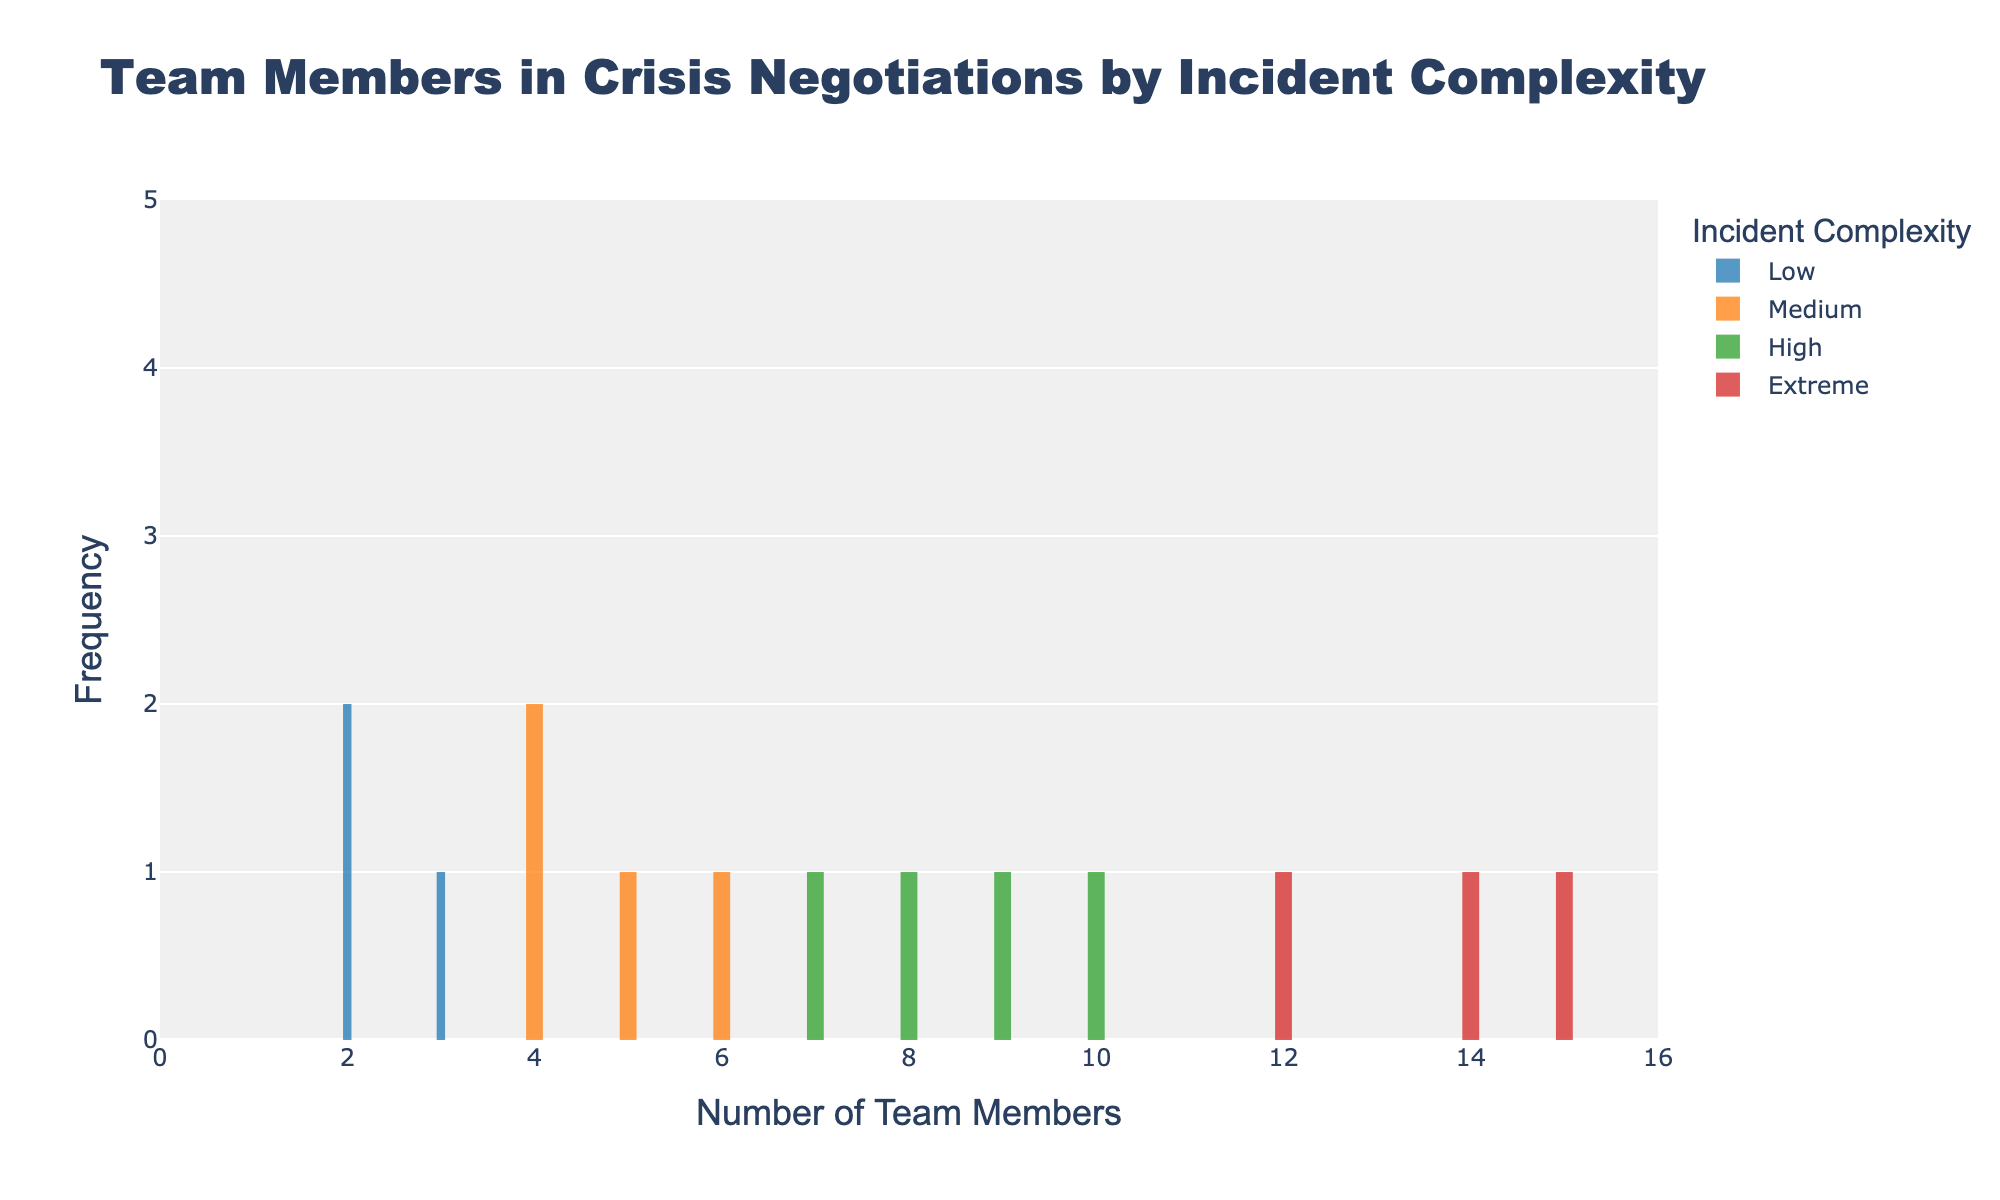What is the title of the histogram? The title is displayed at the top center of the histogram which reads "Team Members in Crisis Negotiations by Incident Complexity".
Answer: Team Members in Crisis Negotiations by Incident Complexity What is the range of the x-axis? The x-axis range can be seen from the x-axis labels. It extends from 0 to the maximum number of team members plus one, which is up to 16.
Answer: 0 to 16 Which incident complexity has the highest number of team members involved? By observing the histogram bars, "Extreme" incident complexity has the highest number of team members with a peak at 15 team members.
Answer: Extreme For the "Medium" incident complexity, how many team members are observed most frequently? In the histogram, the tallest bar for "Medium" incident complexity (orange color) is at 4 team members.
Answer: 4 Which color represents the "High" incident complexity in the histogram? By referring to the legend on the side of the histogram, the color representing "High" incident complexity is green.
Answer: Green How many unique categories of incident complexities are present in the histogram? There are four unique categories of incident complexities listed in the legend: Low, Medium, High, and Extreme.
Answer: 4 What is the frequency range of the y-axis? The y-axis range, as indicated by the y-axis ticks, goes from 0 to 5.
Answer: 0 to 5 Comparing "Low" and "Extreme" complexities, which one has fewer team members on average and why? For "Low", the team member numbers are 2, 3, and 2. For "Extreme," the numbers are 12, 14, and 15. Average for "Low": (2+3+2)/3 = 2.33. Average for "Extreme": (12+14+15)/3 = 13.67. Hence, "Low" has fewer team members on average.
Answer: Low What is the number of team members at the peak of the "High" incident complexity histogram bars? Observing the histogram bars, the "High" incident complexity (green) peaks at 7 team members.
Answer: 7 If you combine the most frequently observed number of team members for "Medium" and "High" incident complexities, what is the total? The most frequently observed number for "Medium" is 4, and for "High" it is 7. Combining them gives 4 + 7 = 11.
Answer: 11 